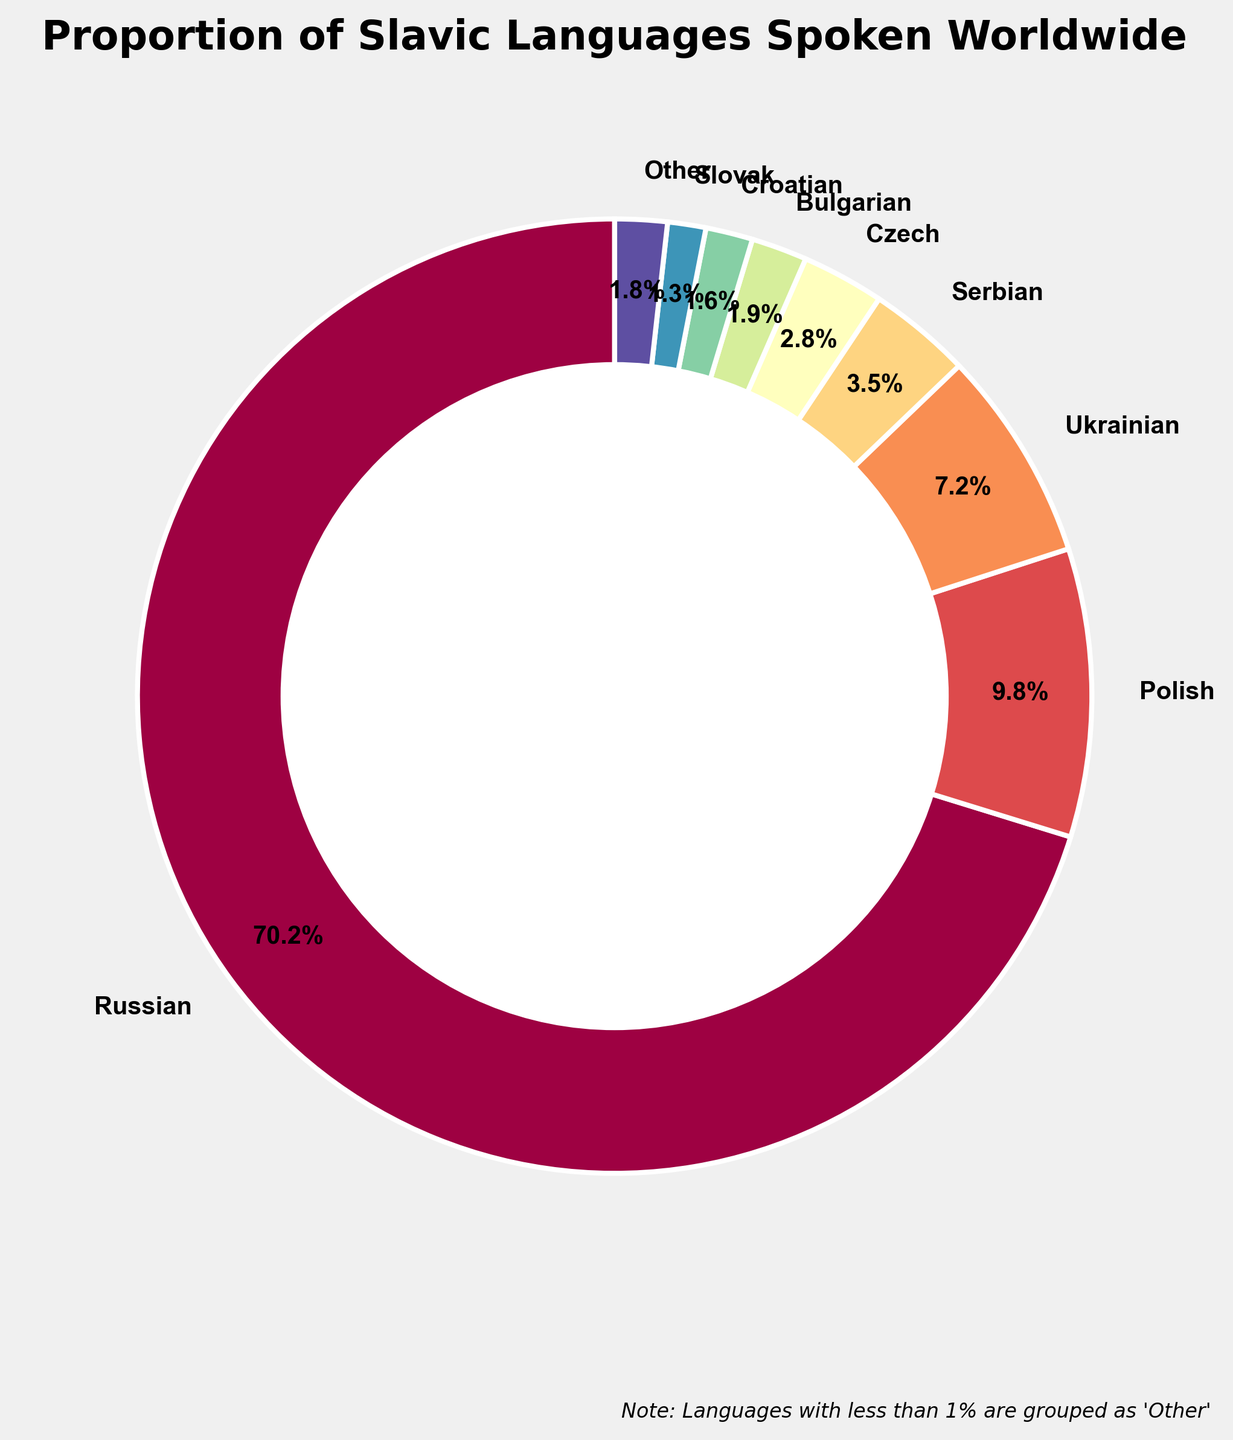what percentage of Slavic languages are grouped into 'Other'? According to the legend in the figure, languages with less than 1% are grouped as 'Other'. If we sum the percentages of all languages with less than 1%, we get the total percentage for 'Other'. Summing 0.8% (Belarusian), 0.5% (Macedonian), 0.4% (Slovene), 0.05% (Upper Sorbian), 0.02% (Lower Sorbian), and 0.01% (Church Slavonic) gives us 1.78%.
Answer: 1.78% Which Slavic language has the second highest proportion spoken worldwide? The pie chart's largest wedge representing Russian is the highest proportion at 70.5%. The wedge next to it is for Polish at 9.8%, making it the second highest.
Answer: Polish How much greater is the proportion of Russian speakers compared to Ukrainian speakers? From the figure, the proportion of Russian speakers is 70.5%, and Ukrainian speakers is 7.2%. Subtracting these two gives us 70.5% - 7.2% = 63.3%.
Answer: 63.3% What is the combined percentage of speakers for the three least common languages grouped as 'Other'? The three least common languages grouped as 'Other' are Upper Sorbian (0.05%), Lower Sorbian (0.02%), and Church Slavonic (0.01%). Their combined percentage is 0.05% + 0.02% + 0.01% = 0.08%.
Answer: 0.08% If Serbian and Croatian were combined into one category, what would their total percentage be? The figure shows the proportion of Serbian speakers is 3.5% and Croatian speakers is 1.6%. Summing these gives 3.5% + 1.6% = 5.1%.
Answer: 5.1% How many languages make up the 'Other' category? The 'Other' category includes Belarusian, Macedonian, Slovene, Upper Sorbian, Lower Sorbian, and Church Slavonic. Counting these gives us 6 languages.
Answer: 6 Between Czech and Bulgarian, which language has a higher proportion spoken worldwide, and by how much? From the figure, the proportion of Czech speakers is 2.8% and Bulgarian speakers is 1.9%. The Czech proportion is higher by 2.8% - 1.9% = 0.9%.
Answer: Czech by 0.9% What proportion of Slavic languages is spoken by more than 5% of the people worldwide? The languages spoken by more than 5% of the people are Russian (70.5%) and Polish (9.8%). Summing these gives 70.5% + 9.8% = 80.3%.
Answer: 80.3% 